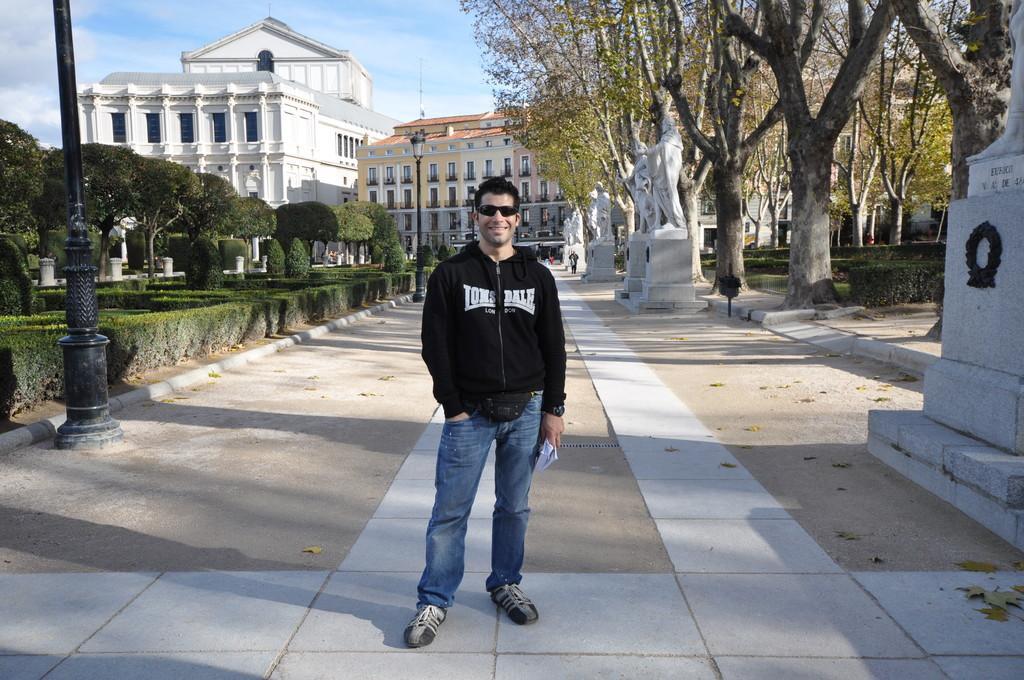How would you summarize this image in a sentence or two? In the image we can see there is a man standing and he is wearing jacket and sunglasses. He is holding papers in his hand and there are trees and plants bushes at the back. There are human statues and behind there are trees and buildings. There are street light poles and there is clear sky. 